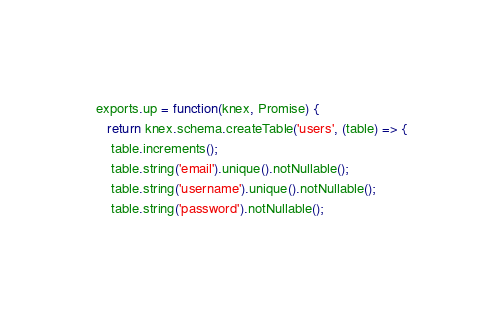Convert code to text. <code><loc_0><loc_0><loc_500><loc_500><_JavaScript_>
exports.up = function(knex, Promise) {
   return knex.schema.createTable('users', (table) => {
    table.increments();
    table.string('email').unique().notNullable();
    table.string('username').unique().notNullable();
    table.string('password').notNullable();</code> 